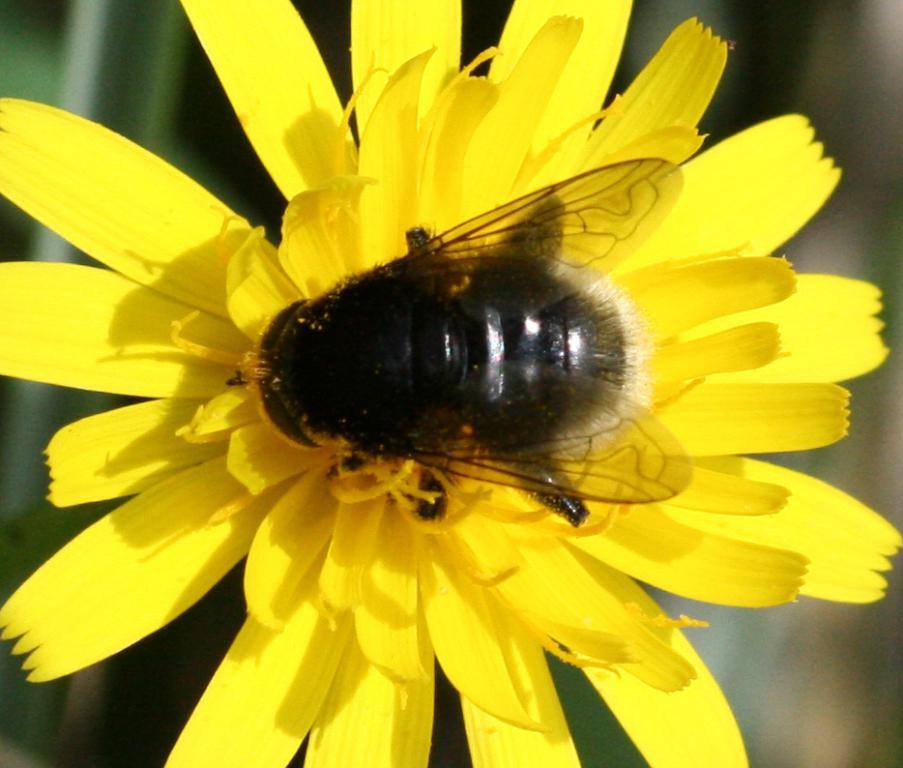What type of creature is present in the image? There is an insect in the image. Where is the insect located in the image? The insect is on a flower. What type of degree does the insect have in the image? There is no indication of any degree in the image, as insects do not obtain degrees. 